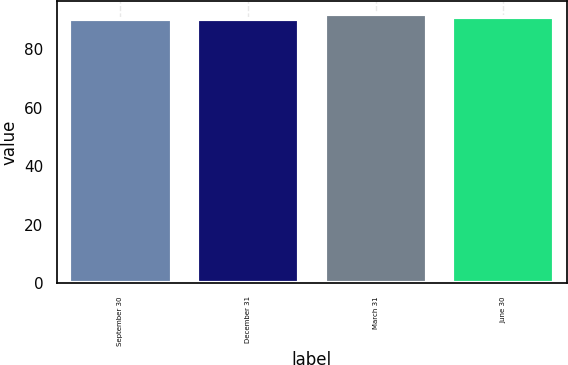<chart> <loc_0><loc_0><loc_500><loc_500><bar_chart><fcel>September 30<fcel>December 31<fcel>March 31<fcel>June 30<nl><fcel>90.22<fcel>90.4<fcel>92<fcel>91.13<nl></chart> 